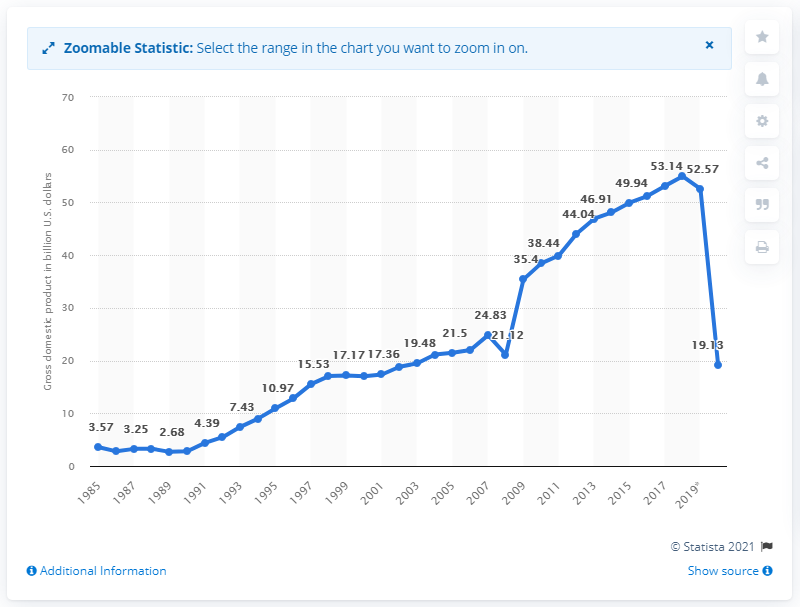Outline some significant characteristics in this image. In 2018, the gross domestic product of Lebanon was 54.96 billion dollars. 